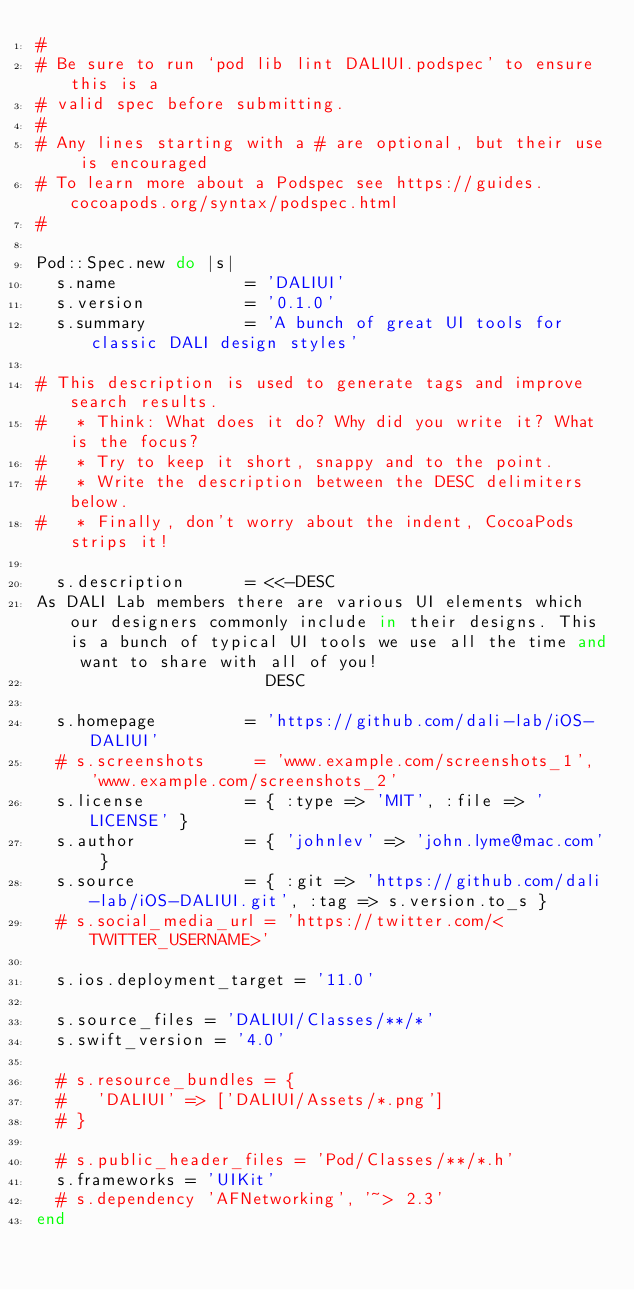<code> <loc_0><loc_0><loc_500><loc_500><_Ruby_>#
# Be sure to run `pod lib lint DALIUI.podspec' to ensure this is a
# valid spec before submitting.
#
# Any lines starting with a # are optional, but their use is encouraged
# To learn more about a Podspec see https://guides.cocoapods.org/syntax/podspec.html
#

Pod::Spec.new do |s|
  s.name             = 'DALIUI'
  s.version          = '0.1.0'
  s.summary          = 'A bunch of great UI tools for classic DALI design styles'

# This description is used to generate tags and improve search results.
#   * Think: What does it do? Why did you write it? What is the focus?
#   * Try to keep it short, snappy and to the point.
#   * Write the description between the DESC delimiters below.
#   * Finally, don't worry about the indent, CocoaPods strips it!

  s.description      = <<-DESC
As DALI Lab members there are various UI elements which our designers commonly include in their designs. This is a bunch of typical UI tools we use all the time and want to share with all of you!
                       DESC

  s.homepage         = 'https://github.com/dali-lab/iOS-DALIUI'
  # s.screenshots     = 'www.example.com/screenshots_1', 'www.example.com/screenshots_2'
  s.license          = { :type => 'MIT', :file => 'LICENSE' }
  s.author           = { 'johnlev' => 'john.lyme@mac.com' }
  s.source           = { :git => 'https://github.com/dali-lab/iOS-DALIUI.git', :tag => s.version.to_s }
  # s.social_media_url = 'https://twitter.com/<TWITTER_USERNAME>'

  s.ios.deployment_target = '11.0'

  s.source_files = 'DALIUI/Classes/**/*'
  s.swift_version = '4.0'
  
  # s.resource_bundles = {
  #   'DALIUI' => ['DALIUI/Assets/*.png']
  # }

  # s.public_header_files = 'Pod/Classes/**/*.h'
  s.frameworks = 'UIKit'
  # s.dependency 'AFNetworking', '~> 2.3'
end
</code> 